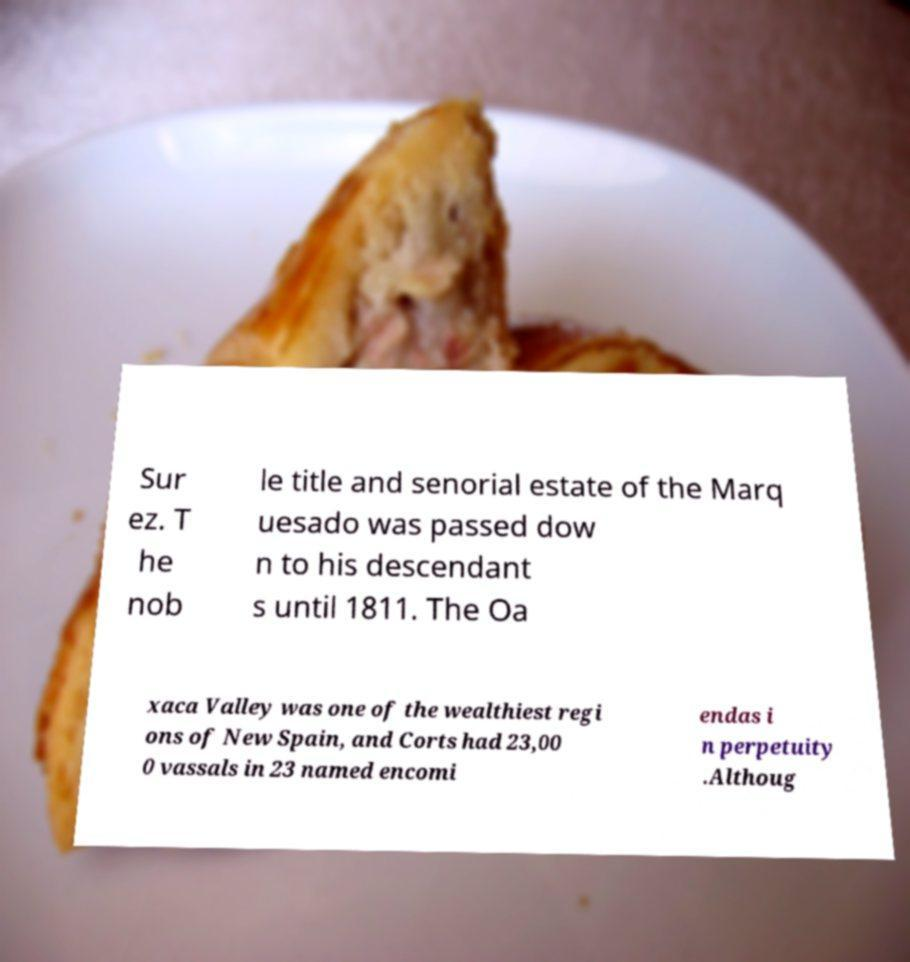Please read and relay the text visible in this image. What does it say? Sur ez. T he nob le title and senorial estate of the Marq uesado was passed dow n to his descendant s until 1811. The Oa xaca Valley was one of the wealthiest regi ons of New Spain, and Corts had 23,00 0 vassals in 23 named encomi endas i n perpetuity .Althoug 